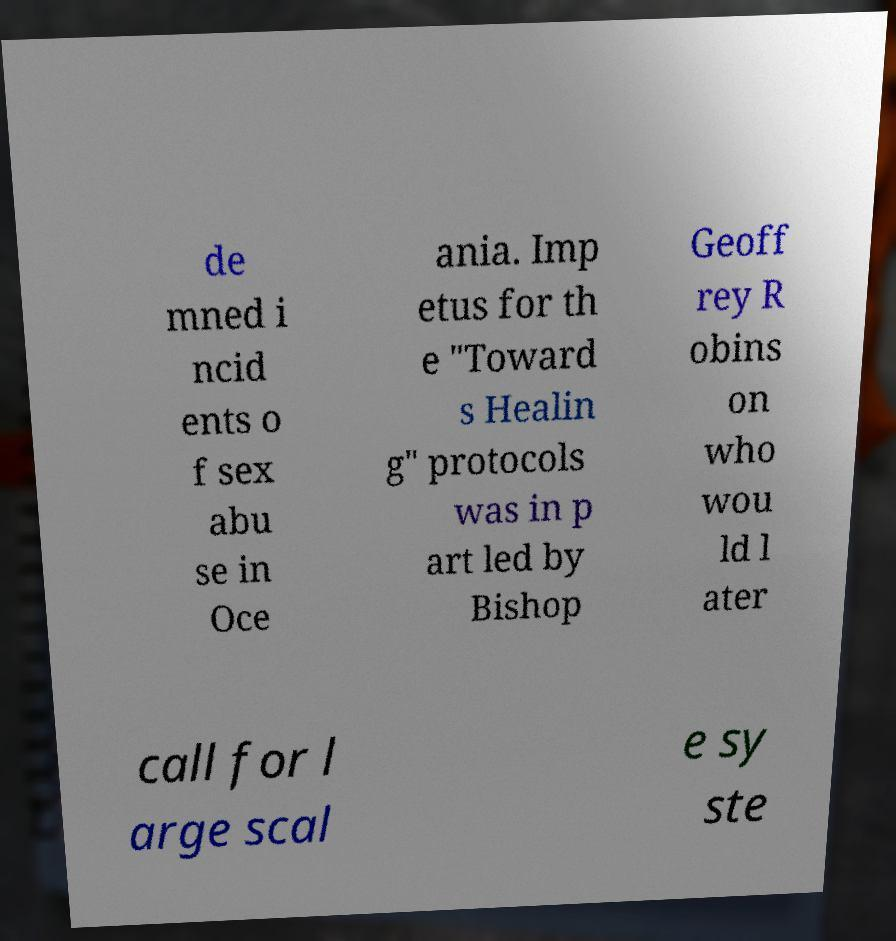Could you extract and type out the text from this image? de mned i ncid ents o f sex abu se in Oce ania. Imp etus for th e "Toward s Healin g" protocols was in p art led by Bishop Geoff rey R obins on who wou ld l ater call for l arge scal e sy ste 